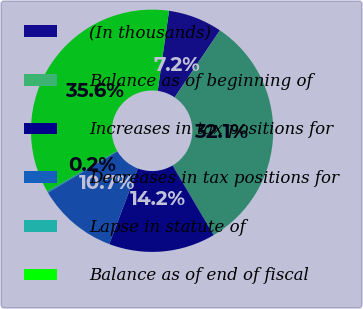Convert chart to OTSL. <chart><loc_0><loc_0><loc_500><loc_500><pie_chart><fcel>(In thousands)<fcel>Balance as of beginning of<fcel>Increases in tax positions for<fcel>Decreases in tax positions for<fcel>Lapse in statute of<fcel>Balance as of end of fiscal<nl><fcel>7.22%<fcel>32.06%<fcel>14.23%<fcel>10.72%<fcel>0.2%<fcel>35.57%<nl></chart> 